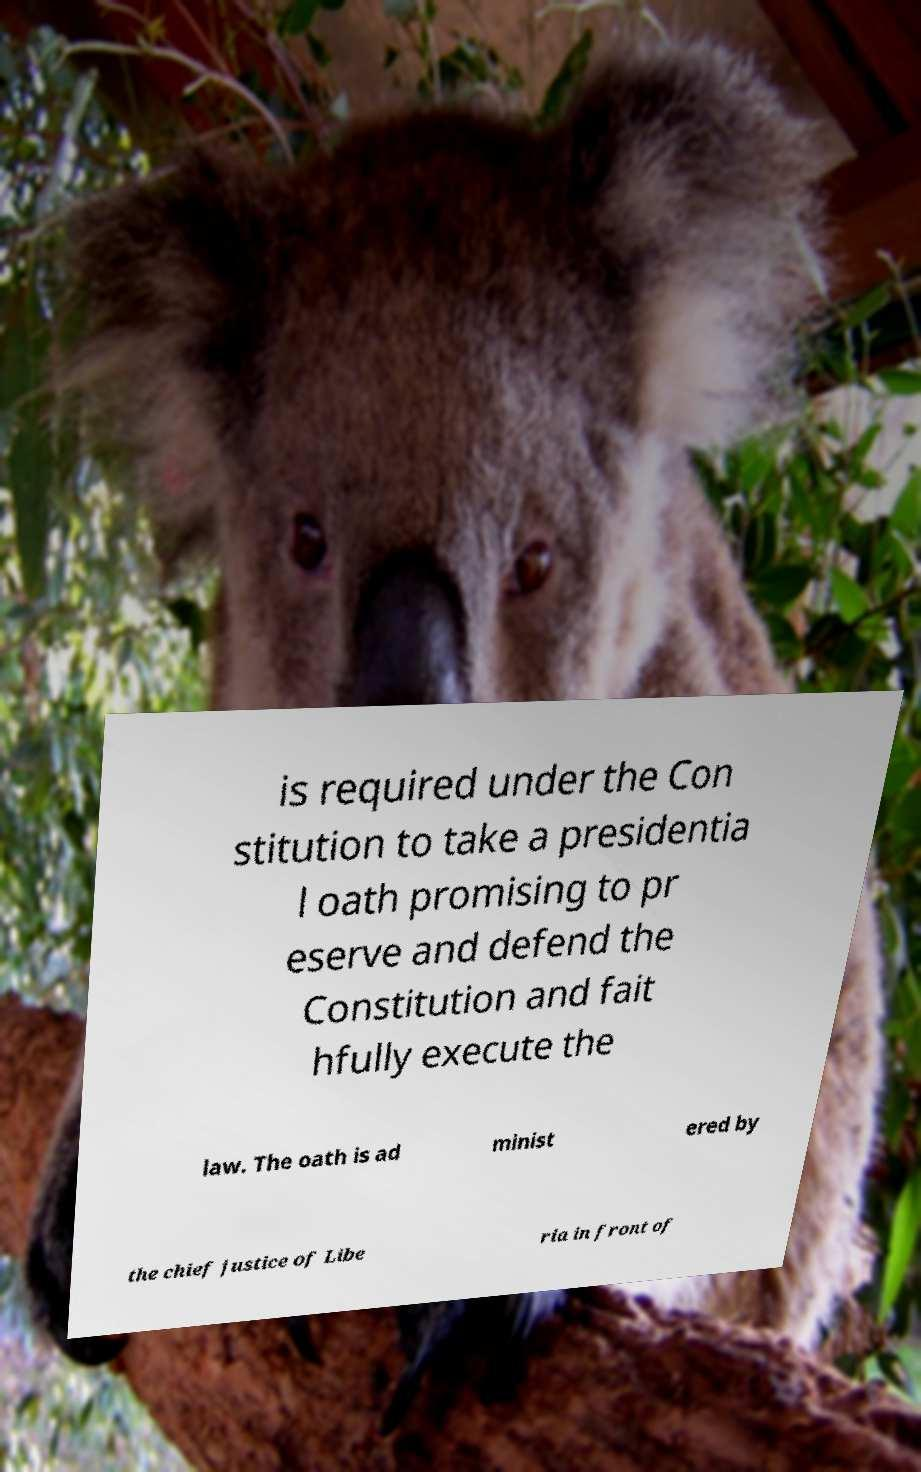Can you read and provide the text displayed in the image?This photo seems to have some interesting text. Can you extract and type it out for me? is required under the Con stitution to take a presidentia l oath promising to pr eserve and defend the Constitution and fait hfully execute the law. The oath is ad minist ered by the chief justice of Libe ria in front of 